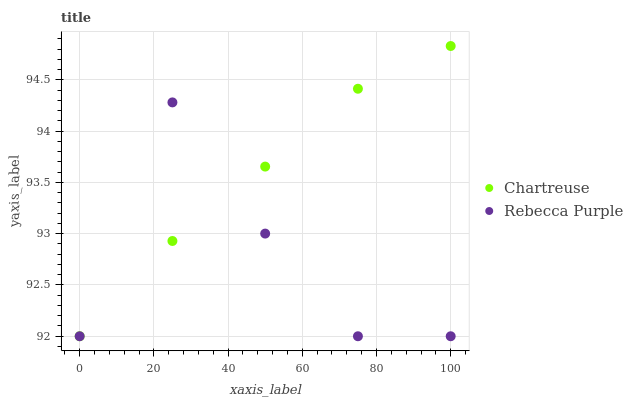Does Rebecca Purple have the minimum area under the curve?
Answer yes or no. Yes. Does Chartreuse have the maximum area under the curve?
Answer yes or no. Yes. Does Rebecca Purple have the maximum area under the curve?
Answer yes or no. No. Is Chartreuse the smoothest?
Answer yes or no. Yes. Is Rebecca Purple the roughest?
Answer yes or no. Yes. Is Rebecca Purple the smoothest?
Answer yes or no. No. Does Chartreuse have the lowest value?
Answer yes or no. Yes. Does Chartreuse have the highest value?
Answer yes or no. Yes. Does Rebecca Purple have the highest value?
Answer yes or no. No. Does Rebecca Purple intersect Chartreuse?
Answer yes or no. Yes. Is Rebecca Purple less than Chartreuse?
Answer yes or no. No. Is Rebecca Purple greater than Chartreuse?
Answer yes or no. No. 